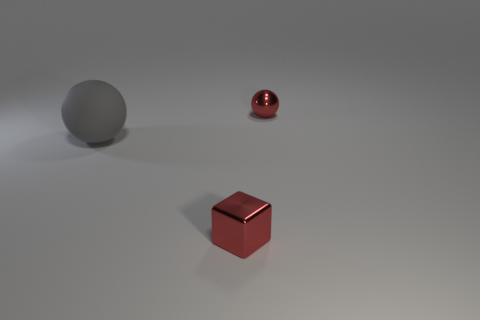How might the placement of the objects affect the composition of this image? The placement of objects in this image has been carefully considered to create balance and interest. The large gray sphere anchors the composition on the left, while the small red cube and the red sphere create focal points that draw the eye. Their positioning along an implied diagonal line creates a sense of dynamism and movement. This composition uses negative space effectively, giving the scene a minimalist, yet intriguing, aesthetic. 